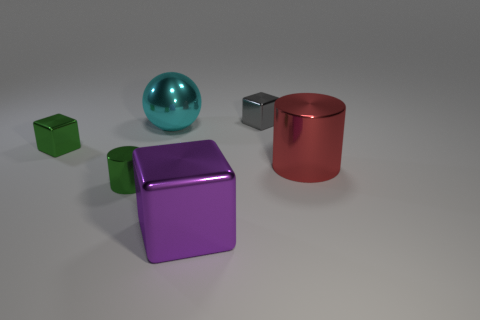Add 3 purple blocks. How many objects exist? 9 Subtract all spheres. How many objects are left? 5 Add 1 small brown cylinders. How many small brown cylinders exist? 1 Subtract 1 red cylinders. How many objects are left? 5 Subtract all balls. Subtract all red shiny objects. How many objects are left? 4 Add 2 metal cubes. How many metal cubes are left? 5 